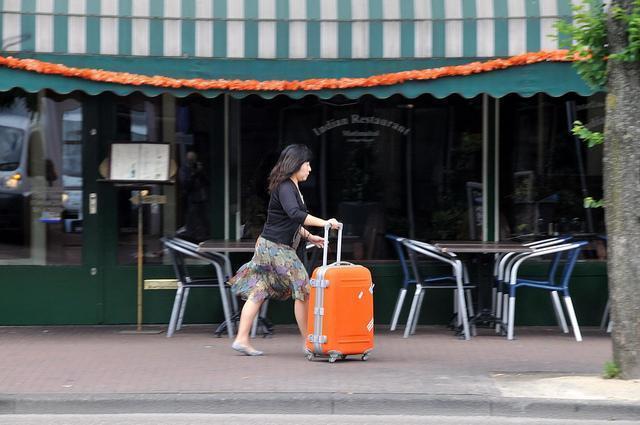How many chairs can you see?
Give a very brief answer. 3. 